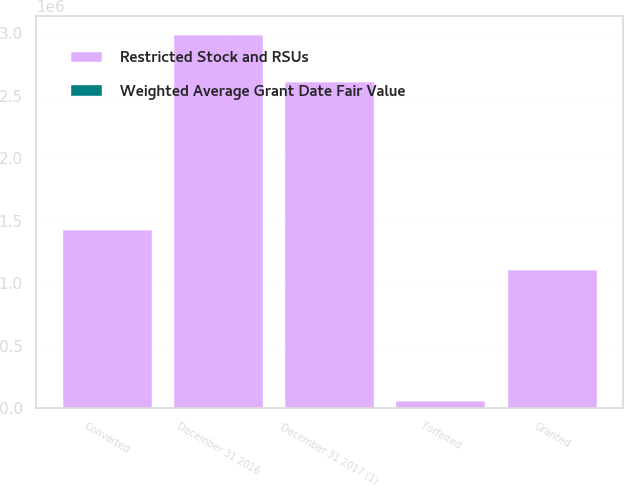Convert chart to OTSL. <chart><loc_0><loc_0><loc_500><loc_500><stacked_bar_chart><ecel><fcel>December 31 2016<fcel>Granted<fcel>Converted<fcel>Forfeited<fcel>December 31 2017 (1)<nl><fcel>Restricted Stock and RSUs<fcel>2.98759e+06<fcel>1.10421e+06<fcel>1.42465e+06<fcel>58481<fcel>2.60867e+06<nl><fcel>Weighted Average Grant Date Fair Value<fcel>318.04<fcel>381.62<fcel>321.12<fcel>339.17<fcel>342.79<nl></chart> 